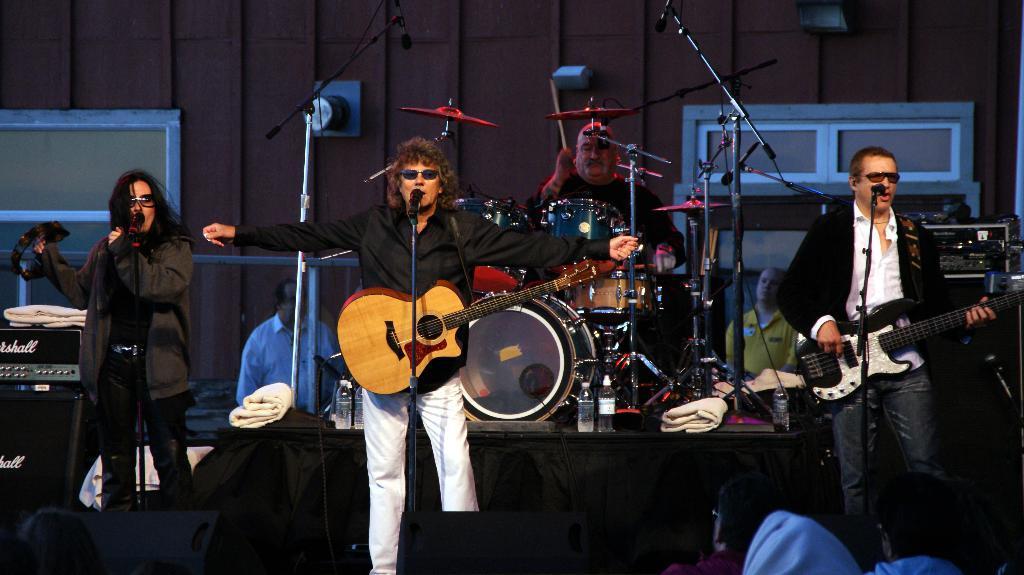Can you describe this image briefly? It is a music show, there are lot of music instruments and also people to play the instruments, in the background there is a brown color wall and two windows to the wall, to the left side there is a music system and speakers. 